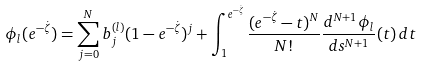Convert formula to latex. <formula><loc_0><loc_0><loc_500><loc_500>\phi _ { l } ( e ^ { - \dot { \zeta } } ) = \sum _ { j = 0 } ^ { N } b _ { j } ^ { ( l ) } ( 1 - e ^ { - \dot { \zeta } } ) ^ { j } + \int _ { 1 } ^ { e ^ { - \dot { \zeta } } } \frac { ( e ^ { - \dot { \zeta } } - t ) ^ { N } } { N ! } \frac { d ^ { N + 1 } \phi _ { l } } { d s ^ { N + 1 } } ( t ) \, d t</formula> 